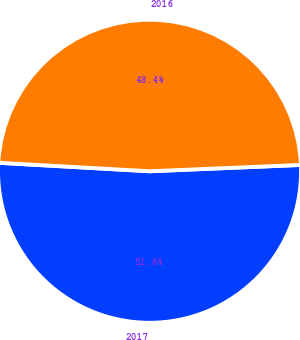Convert chart. <chart><loc_0><loc_0><loc_500><loc_500><pie_chart><fcel>2017<fcel>2016<nl><fcel>51.56%<fcel>48.44%<nl></chart> 